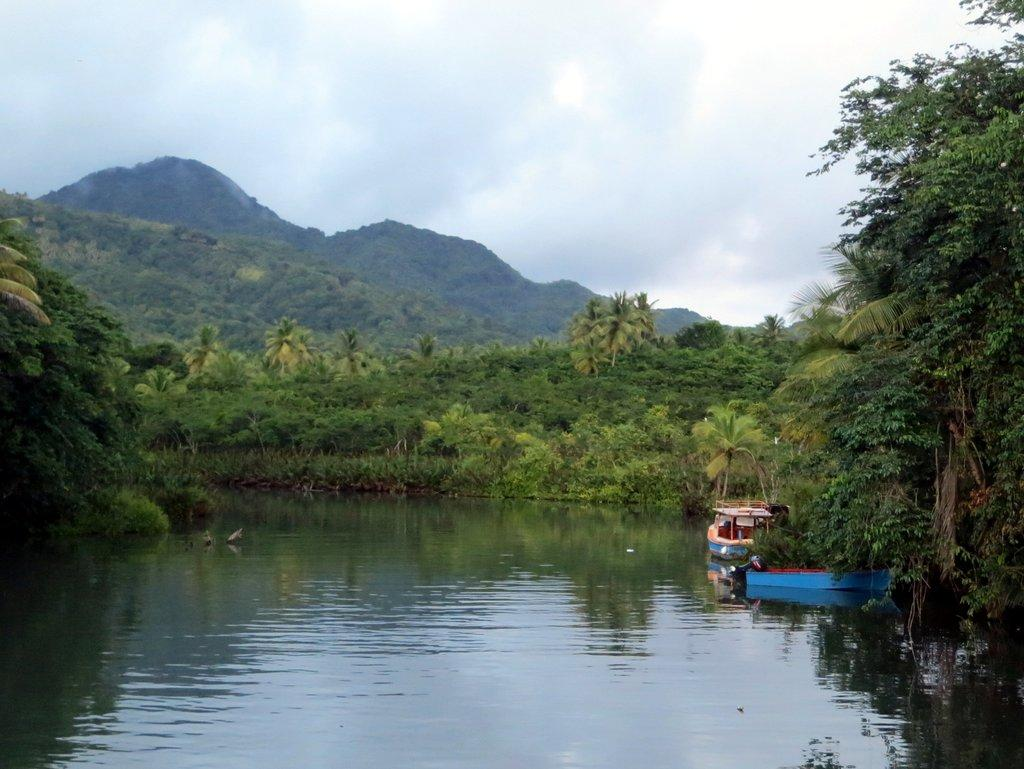How many boats are in the image? There are two boats in the image. Where are the boats located? The boats are on the water. What can be seen in the background of the image? There are trees, hills, and a cloudy sky visible in the background of the image. What type of advertisement can be seen on the boats in the image? There are no advertisements visible on the boats in the image. What is the purpose of the boats in the image? The purpose of the boats in the image cannot be determined without additional context. 